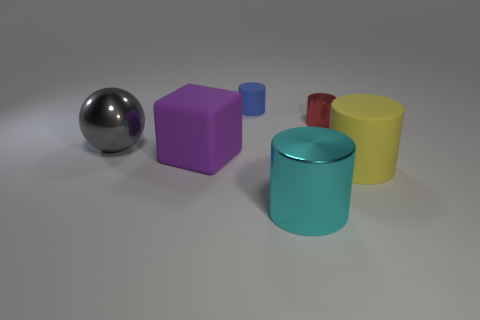What number of cyan shiny objects have the same size as the cyan metallic cylinder?
Your answer should be very brief. 0. What is the color of the big matte object that is on the left side of the yellow rubber object?
Make the answer very short. Purple. What number of other objects are there of the same size as the cyan metallic cylinder?
Make the answer very short. 3. What size is the metal object that is both on the right side of the big gray thing and to the left of the red metallic cylinder?
Your response must be concise. Large. Do the big shiny cylinder and the rubber object that is in front of the large matte block have the same color?
Offer a terse response. No. Is there a gray matte thing that has the same shape as the blue rubber object?
Provide a succinct answer. No. What number of things are small gray matte cylinders or large matte things that are behind the big yellow cylinder?
Provide a succinct answer. 1. What number of other objects are the same material as the tiny red cylinder?
Keep it short and to the point. 2. How many things are either big gray shiny spheres or large gray metal cubes?
Keep it short and to the point. 1. Are there more large gray spheres that are to the right of the purple rubber object than metal cylinders left of the tiny blue rubber cylinder?
Provide a succinct answer. No. 